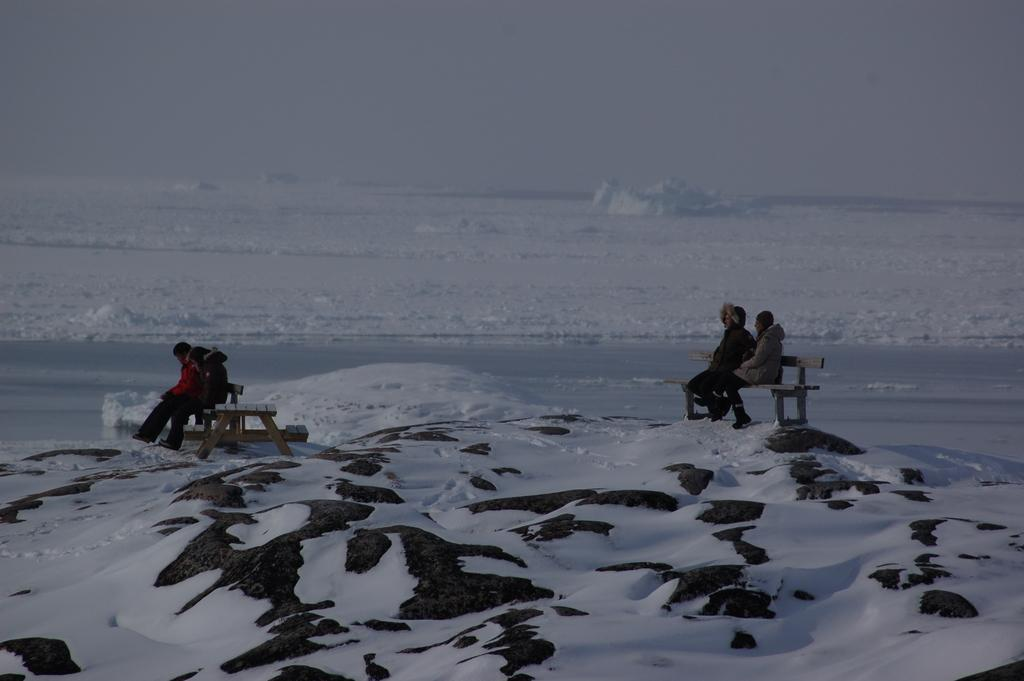What is the primary element in the foreground of the image? There is snow in the foreground of the image. How many people are present in the image? There are four persons in the image. What are the persons sitting on? The persons are sitting on wooden benches. What type of clothing are the persons wearing? The persons are wearing jackets. What type of balls can be seen in the image? There are no balls present in the image. What is the oven used for in the image? There is no oven present in the image. 